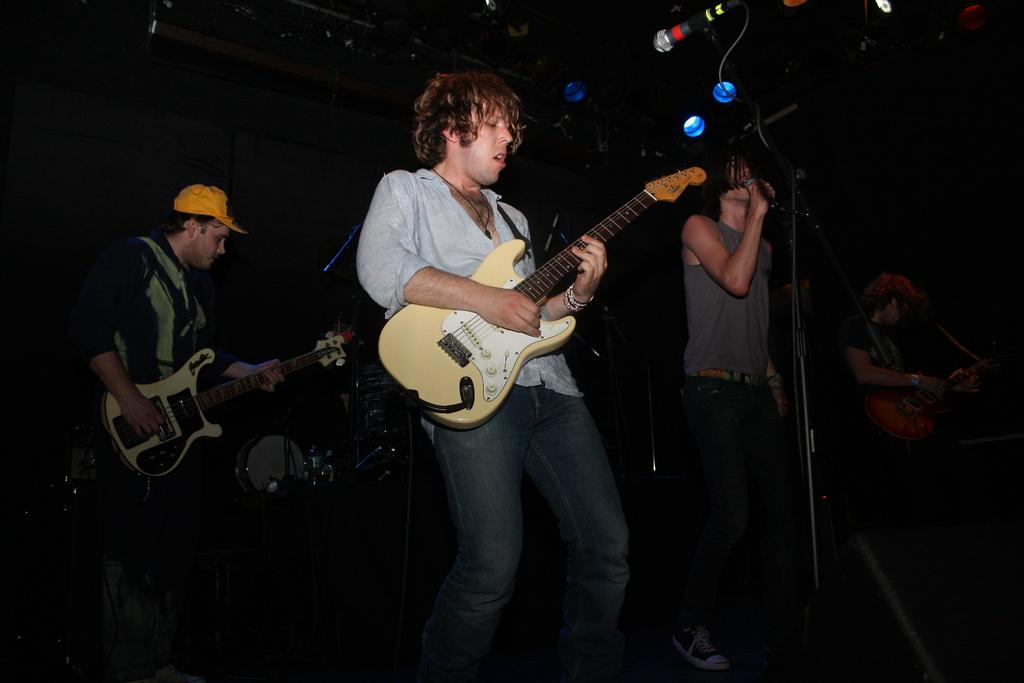How many people are in the image? There are three people in the image. What are two of the people holding? Two of the people are holding guitars. What other object can be seen in the image? There is a microphone (mic) in the image. How many bears are playing with the guitars in the image? There are no bears present in the image, and therefore no bears are playing with the guitars. What type of coat is being worn by the rabbits in the image? There are no rabbits present in the image, and therefore no coats are being worn by them. 